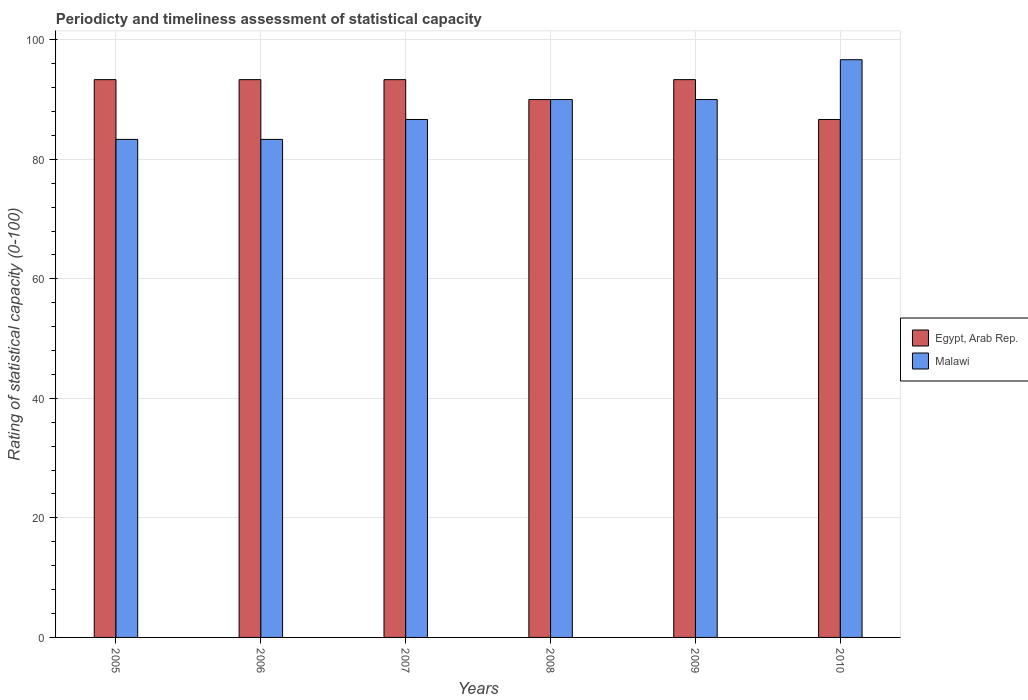How many different coloured bars are there?
Your response must be concise. 2. Are the number of bars per tick equal to the number of legend labels?
Provide a succinct answer. Yes. Are the number of bars on each tick of the X-axis equal?
Offer a very short reply. Yes. How many bars are there on the 2nd tick from the left?
Your response must be concise. 2. In how many cases, is the number of bars for a given year not equal to the number of legend labels?
Make the answer very short. 0. What is the rating of statistical capacity in Egypt, Arab Rep. in 2007?
Give a very brief answer. 93.33. Across all years, what is the maximum rating of statistical capacity in Malawi?
Give a very brief answer. 96.67. Across all years, what is the minimum rating of statistical capacity in Egypt, Arab Rep.?
Make the answer very short. 86.67. What is the total rating of statistical capacity in Malawi in the graph?
Offer a terse response. 530. What is the difference between the rating of statistical capacity in Malawi in 2006 and that in 2007?
Provide a succinct answer. -3.33. What is the difference between the rating of statistical capacity in Malawi in 2005 and the rating of statistical capacity in Egypt, Arab Rep. in 2009?
Ensure brevity in your answer.  -10. What is the average rating of statistical capacity in Malawi per year?
Provide a succinct answer. 88.33. In the year 2009, what is the difference between the rating of statistical capacity in Malawi and rating of statistical capacity in Egypt, Arab Rep.?
Ensure brevity in your answer.  -3.33. In how many years, is the rating of statistical capacity in Malawi greater than 84?
Make the answer very short. 4. What is the ratio of the rating of statistical capacity in Malawi in 2008 to that in 2010?
Your answer should be compact. 0.93. Is the difference between the rating of statistical capacity in Malawi in 2007 and 2009 greater than the difference between the rating of statistical capacity in Egypt, Arab Rep. in 2007 and 2009?
Offer a very short reply. No. What is the difference between the highest and the second highest rating of statistical capacity in Malawi?
Ensure brevity in your answer.  6.67. What is the difference between the highest and the lowest rating of statistical capacity in Egypt, Arab Rep.?
Offer a very short reply. 6.67. In how many years, is the rating of statistical capacity in Egypt, Arab Rep. greater than the average rating of statistical capacity in Egypt, Arab Rep. taken over all years?
Keep it short and to the point. 4. What does the 2nd bar from the left in 2007 represents?
Provide a succinct answer. Malawi. What does the 1st bar from the right in 2006 represents?
Keep it short and to the point. Malawi. How many bars are there?
Offer a terse response. 12. Does the graph contain any zero values?
Your answer should be very brief. No. Where does the legend appear in the graph?
Ensure brevity in your answer.  Center right. What is the title of the graph?
Offer a terse response. Periodicty and timeliness assessment of statistical capacity. Does "Bosnia and Herzegovina" appear as one of the legend labels in the graph?
Your answer should be very brief. No. What is the label or title of the X-axis?
Keep it short and to the point. Years. What is the label or title of the Y-axis?
Your answer should be very brief. Rating of statistical capacity (0-100). What is the Rating of statistical capacity (0-100) in Egypt, Arab Rep. in 2005?
Give a very brief answer. 93.33. What is the Rating of statistical capacity (0-100) in Malawi in 2005?
Your response must be concise. 83.33. What is the Rating of statistical capacity (0-100) in Egypt, Arab Rep. in 2006?
Your answer should be compact. 93.33. What is the Rating of statistical capacity (0-100) of Malawi in 2006?
Give a very brief answer. 83.33. What is the Rating of statistical capacity (0-100) of Egypt, Arab Rep. in 2007?
Offer a terse response. 93.33. What is the Rating of statistical capacity (0-100) of Malawi in 2007?
Keep it short and to the point. 86.67. What is the Rating of statistical capacity (0-100) of Egypt, Arab Rep. in 2008?
Provide a short and direct response. 90. What is the Rating of statistical capacity (0-100) in Malawi in 2008?
Offer a very short reply. 90. What is the Rating of statistical capacity (0-100) of Egypt, Arab Rep. in 2009?
Your answer should be very brief. 93.33. What is the Rating of statistical capacity (0-100) of Egypt, Arab Rep. in 2010?
Your answer should be compact. 86.67. What is the Rating of statistical capacity (0-100) of Malawi in 2010?
Keep it short and to the point. 96.67. Across all years, what is the maximum Rating of statistical capacity (0-100) of Egypt, Arab Rep.?
Make the answer very short. 93.33. Across all years, what is the maximum Rating of statistical capacity (0-100) of Malawi?
Make the answer very short. 96.67. Across all years, what is the minimum Rating of statistical capacity (0-100) of Egypt, Arab Rep.?
Offer a terse response. 86.67. Across all years, what is the minimum Rating of statistical capacity (0-100) of Malawi?
Offer a terse response. 83.33. What is the total Rating of statistical capacity (0-100) of Egypt, Arab Rep. in the graph?
Make the answer very short. 550. What is the total Rating of statistical capacity (0-100) in Malawi in the graph?
Make the answer very short. 530. What is the difference between the Rating of statistical capacity (0-100) of Egypt, Arab Rep. in 2005 and that in 2006?
Ensure brevity in your answer.  0. What is the difference between the Rating of statistical capacity (0-100) in Egypt, Arab Rep. in 2005 and that in 2007?
Keep it short and to the point. 0. What is the difference between the Rating of statistical capacity (0-100) in Egypt, Arab Rep. in 2005 and that in 2008?
Your response must be concise. 3.33. What is the difference between the Rating of statistical capacity (0-100) of Malawi in 2005 and that in 2008?
Offer a terse response. -6.67. What is the difference between the Rating of statistical capacity (0-100) of Egypt, Arab Rep. in 2005 and that in 2009?
Keep it short and to the point. 0. What is the difference between the Rating of statistical capacity (0-100) of Malawi in 2005 and that in 2009?
Provide a short and direct response. -6.67. What is the difference between the Rating of statistical capacity (0-100) of Egypt, Arab Rep. in 2005 and that in 2010?
Provide a short and direct response. 6.67. What is the difference between the Rating of statistical capacity (0-100) of Malawi in 2005 and that in 2010?
Provide a short and direct response. -13.33. What is the difference between the Rating of statistical capacity (0-100) in Egypt, Arab Rep. in 2006 and that in 2007?
Your response must be concise. 0. What is the difference between the Rating of statistical capacity (0-100) in Malawi in 2006 and that in 2007?
Offer a very short reply. -3.33. What is the difference between the Rating of statistical capacity (0-100) in Malawi in 2006 and that in 2008?
Ensure brevity in your answer.  -6.67. What is the difference between the Rating of statistical capacity (0-100) in Egypt, Arab Rep. in 2006 and that in 2009?
Provide a succinct answer. 0. What is the difference between the Rating of statistical capacity (0-100) in Malawi in 2006 and that in 2009?
Ensure brevity in your answer.  -6.67. What is the difference between the Rating of statistical capacity (0-100) in Egypt, Arab Rep. in 2006 and that in 2010?
Ensure brevity in your answer.  6.67. What is the difference between the Rating of statistical capacity (0-100) of Malawi in 2006 and that in 2010?
Your response must be concise. -13.33. What is the difference between the Rating of statistical capacity (0-100) in Egypt, Arab Rep. in 2007 and that in 2008?
Provide a succinct answer. 3.33. What is the difference between the Rating of statistical capacity (0-100) in Malawi in 2007 and that in 2008?
Keep it short and to the point. -3.33. What is the difference between the Rating of statistical capacity (0-100) in Egypt, Arab Rep. in 2007 and that in 2009?
Give a very brief answer. 0. What is the difference between the Rating of statistical capacity (0-100) of Malawi in 2007 and that in 2009?
Your answer should be very brief. -3.33. What is the difference between the Rating of statistical capacity (0-100) in Egypt, Arab Rep. in 2008 and that in 2010?
Offer a terse response. 3.33. What is the difference between the Rating of statistical capacity (0-100) of Malawi in 2008 and that in 2010?
Offer a very short reply. -6.67. What is the difference between the Rating of statistical capacity (0-100) of Egypt, Arab Rep. in 2009 and that in 2010?
Provide a short and direct response. 6.67. What is the difference between the Rating of statistical capacity (0-100) in Malawi in 2009 and that in 2010?
Give a very brief answer. -6.67. What is the difference between the Rating of statistical capacity (0-100) of Egypt, Arab Rep. in 2005 and the Rating of statistical capacity (0-100) of Malawi in 2010?
Your answer should be very brief. -3.33. What is the difference between the Rating of statistical capacity (0-100) of Egypt, Arab Rep. in 2006 and the Rating of statistical capacity (0-100) of Malawi in 2007?
Your response must be concise. 6.67. What is the difference between the Rating of statistical capacity (0-100) of Egypt, Arab Rep. in 2006 and the Rating of statistical capacity (0-100) of Malawi in 2010?
Offer a very short reply. -3.33. What is the difference between the Rating of statistical capacity (0-100) of Egypt, Arab Rep. in 2007 and the Rating of statistical capacity (0-100) of Malawi in 2008?
Offer a very short reply. 3.33. What is the difference between the Rating of statistical capacity (0-100) of Egypt, Arab Rep. in 2008 and the Rating of statistical capacity (0-100) of Malawi in 2009?
Make the answer very short. 0. What is the difference between the Rating of statistical capacity (0-100) in Egypt, Arab Rep. in 2008 and the Rating of statistical capacity (0-100) in Malawi in 2010?
Provide a short and direct response. -6.67. What is the average Rating of statistical capacity (0-100) of Egypt, Arab Rep. per year?
Your answer should be very brief. 91.67. What is the average Rating of statistical capacity (0-100) in Malawi per year?
Make the answer very short. 88.33. In the year 2005, what is the difference between the Rating of statistical capacity (0-100) in Egypt, Arab Rep. and Rating of statistical capacity (0-100) in Malawi?
Provide a short and direct response. 10. In the year 2007, what is the difference between the Rating of statistical capacity (0-100) in Egypt, Arab Rep. and Rating of statistical capacity (0-100) in Malawi?
Your answer should be compact. 6.67. In the year 2008, what is the difference between the Rating of statistical capacity (0-100) in Egypt, Arab Rep. and Rating of statistical capacity (0-100) in Malawi?
Give a very brief answer. 0. In the year 2009, what is the difference between the Rating of statistical capacity (0-100) of Egypt, Arab Rep. and Rating of statistical capacity (0-100) of Malawi?
Your answer should be compact. 3.33. In the year 2010, what is the difference between the Rating of statistical capacity (0-100) of Egypt, Arab Rep. and Rating of statistical capacity (0-100) of Malawi?
Offer a very short reply. -10. What is the ratio of the Rating of statistical capacity (0-100) of Malawi in 2005 to that in 2007?
Ensure brevity in your answer.  0.96. What is the ratio of the Rating of statistical capacity (0-100) of Malawi in 2005 to that in 2008?
Offer a terse response. 0.93. What is the ratio of the Rating of statistical capacity (0-100) of Egypt, Arab Rep. in 2005 to that in 2009?
Keep it short and to the point. 1. What is the ratio of the Rating of statistical capacity (0-100) of Malawi in 2005 to that in 2009?
Give a very brief answer. 0.93. What is the ratio of the Rating of statistical capacity (0-100) in Malawi in 2005 to that in 2010?
Provide a succinct answer. 0.86. What is the ratio of the Rating of statistical capacity (0-100) of Malawi in 2006 to that in 2007?
Ensure brevity in your answer.  0.96. What is the ratio of the Rating of statistical capacity (0-100) of Egypt, Arab Rep. in 2006 to that in 2008?
Give a very brief answer. 1.04. What is the ratio of the Rating of statistical capacity (0-100) in Malawi in 2006 to that in 2008?
Your answer should be compact. 0.93. What is the ratio of the Rating of statistical capacity (0-100) of Malawi in 2006 to that in 2009?
Provide a succinct answer. 0.93. What is the ratio of the Rating of statistical capacity (0-100) of Egypt, Arab Rep. in 2006 to that in 2010?
Provide a succinct answer. 1.08. What is the ratio of the Rating of statistical capacity (0-100) of Malawi in 2006 to that in 2010?
Provide a short and direct response. 0.86. What is the ratio of the Rating of statistical capacity (0-100) in Egypt, Arab Rep. in 2007 to that in 2008?
Ensure brevity in your answer.  1.04. What is the ratio of the Rating of statistical capacity (0-100) of Egypt, Arab Rep. in 2007 to that in 2009?
Give a very brief answer. 1. What is the ratio of the Rating of statistical capacity (0-100) of Malawi in 2007 to that in 2009?
Offer a terse response. 0.96. What is the ratio of the Rating of statistical capacity (0-100) of Egypt, Arab Rep. in 2007 to that in 2010?
Provide a short and direct response. 1.08. What is the ratio of the Rating of statistical capacity (0-100) in Malawi in 2007 to that in 2010?
Give a very brief answer. 0.9. What is the ratio of the Rating of statistical capacity (0-100) of Egypt, Arab Rep. in 2008 to that in 2009?
Give a very brief answer. 0.96. What is the ratio of the Rating of statistical capacity (0-100) of Egypt, Arab Rep. in 2008 to that in 2010?
Keep it short and to the point. 1.04. What is the difference between the highest and the lowest Rating of statistical capacity (0-100) in Malawi?
Provide a short and direct response. 13.33. 